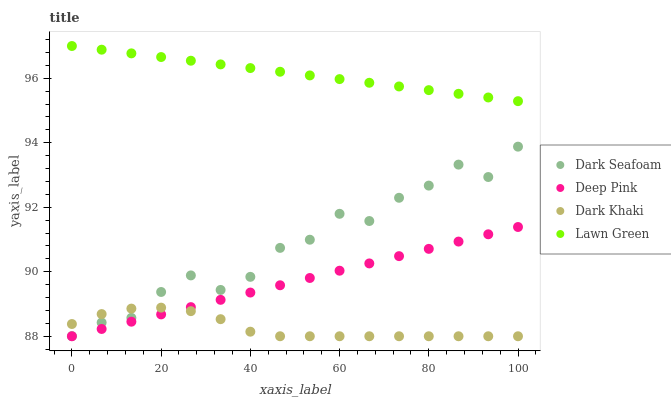Does Dark Khaki have the minimum area under the curve?
Answer yes or no. Yes. Does Lawn Green have the maximum area under the curve?
Answer yes or no. Yes. Does Dark Seafoam have the minimum area under the curve?
Answer yes or no. No. Does Dark Seafoam have the maximum area under the curve?
Answer yes or no. No. Is Lawn Green the smoothest?
Answer yes or no. Yes. Is Dark Seafoam the roughest?
Answer yes or no. Yes. Is Dark Seafoam the smoothest?
Answer yes or no. No. Is Lawn Green the roughest?
Answer yes or no. No. Does Dark Khaki have the lowest value?
Answer yes or no. Yes. Does Dark Seafoam have the lowest value?
Answer yes or no. No. Does Lawn Green have the highest value?
Answer yes or no. Yes. Does Dark Seafoam have the highest value?
Answer yes or no. No. Is Dark Khaki less than Lawn Green?
Answer yes or no. Yes. Is Lawn Green greater than Dark Khaki?
Answer yes or no. Yes. Does Dark Seafoam intersect Dark Khaki?
Answer yes or no. Yes. Is Dark Seafoam less than Dark Khaki?
Answer yes or no. No. Is Dark Seafoam greater than Dark Khaki?
Answer yes or no. No. Does Dark Khaki intersect Lawn Green?
Answer yes or no. No. 